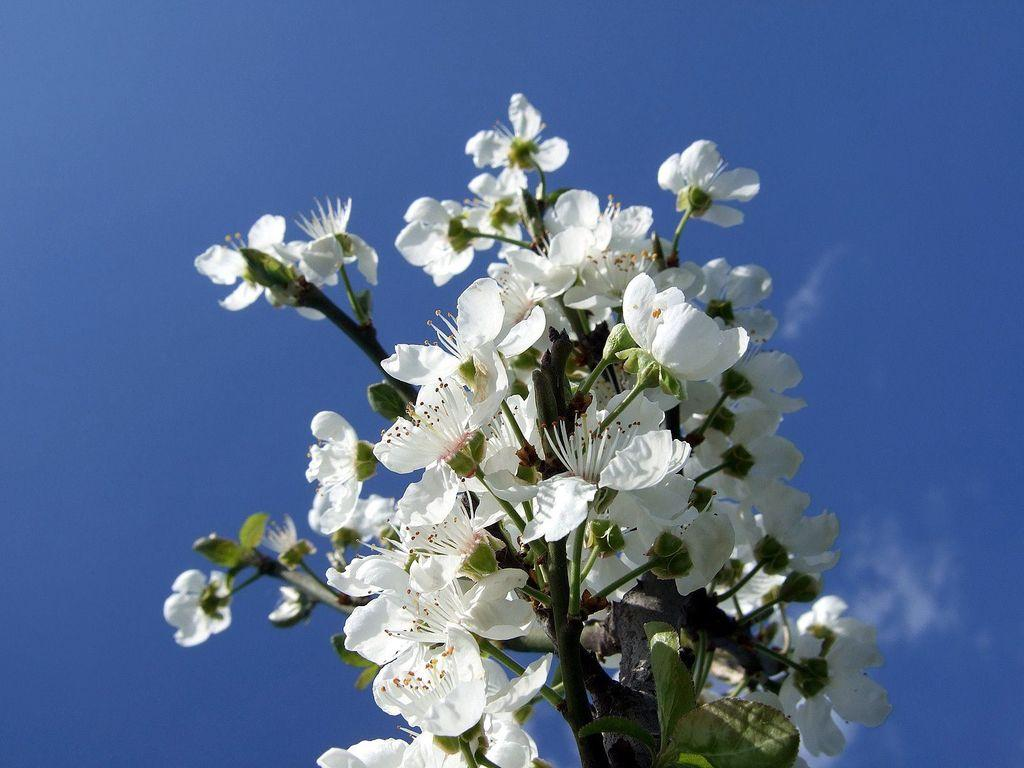What type of living organisms can be seen in the image? There are flowers and a plant visible in the image. What can be seen in the background of the image? The sky is visible in the background of the image. What type of pancake can be seen in the image? There is no pancake present in the image. How is the thread used in the image? There is no thread present in the image. 